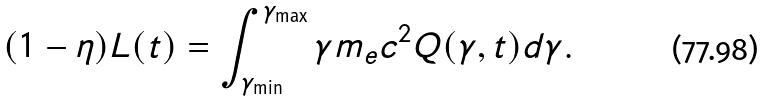Convert formula to latex. <formula><loc_0><loc_0><loc_500><loc_500>( 1 - \eta ) L ( t ) = \int _ { \gamma _ { \min } } ^ { \gamma _ { \max } } \gamma m _ { e } c ^ { 2 } Q ( \gamma , t ) d \gamma .</formula> 